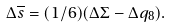Convert formula to latex. <formula><loc_0><loc_0><loc_500><loc_500>\Delta { \overline { s } } = ( 1 / 6 ) ( \Delta \Sigma - \Delta q _ { 8 } ) .</formula> 